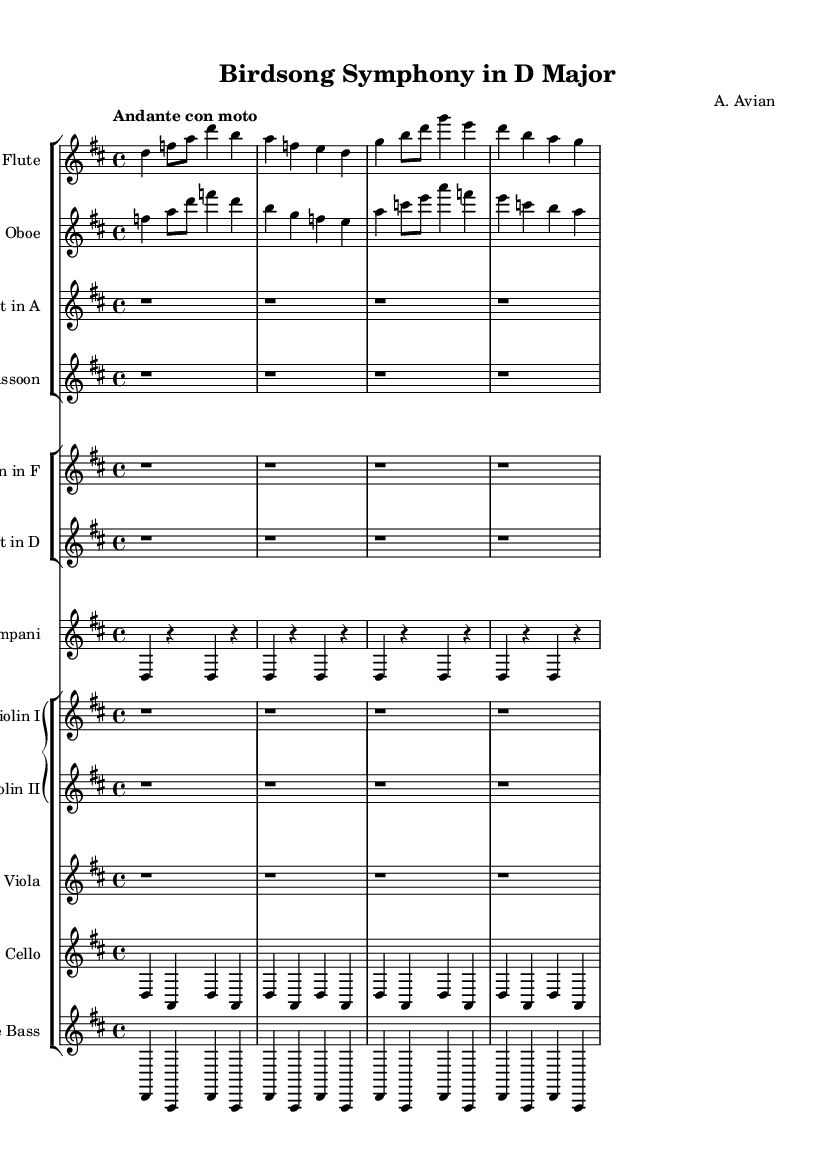What is the key signature of this music? The key signature is indicated at the beginning of the staff, showing two sharps. This corresponds to the D major scale.
Answer: D major What is the time signature of this music? The time signature is found at the beginning of the score, represented by the numbers 4 over 4, indicating a typical four-beat measure.
Answer: 4/4 What is the tempo marking for this symphony? The tempo marking "Andante con moto" is placed above the beginning of the music, indicating a moderate tempo with some motion.
Answer: Andante con moto How many measures are in the flute part? The flute part consists of four measures, as each segment of the music divided by the bar lines represents one measure.
Answer: 4 Which instruments have rests throughout the score? Looking at the score, the clarinet, bassoon, horn, and trumpet parts consist entirely of rests for the entire score, as indicated by the absence of notes.
Answer: Clarinet, Bassoon, Horn, Trumpet What section of the orchestra is commonly associated with depicting pastoral scenes in Romantic-era symphonies? The woodwind section, including instruments like the flute and oboe, is often used to represent the soft, lyrical qualities of nature in Romantic music, as seen in the melodic lines.
Answer: Woodwind section Which instrument provides the foundation in the low register? The double bass part plays a similar rhythm to the cello, providing a harmonic foundation in the lower register of the orchestration.
Answer: Double Bass 